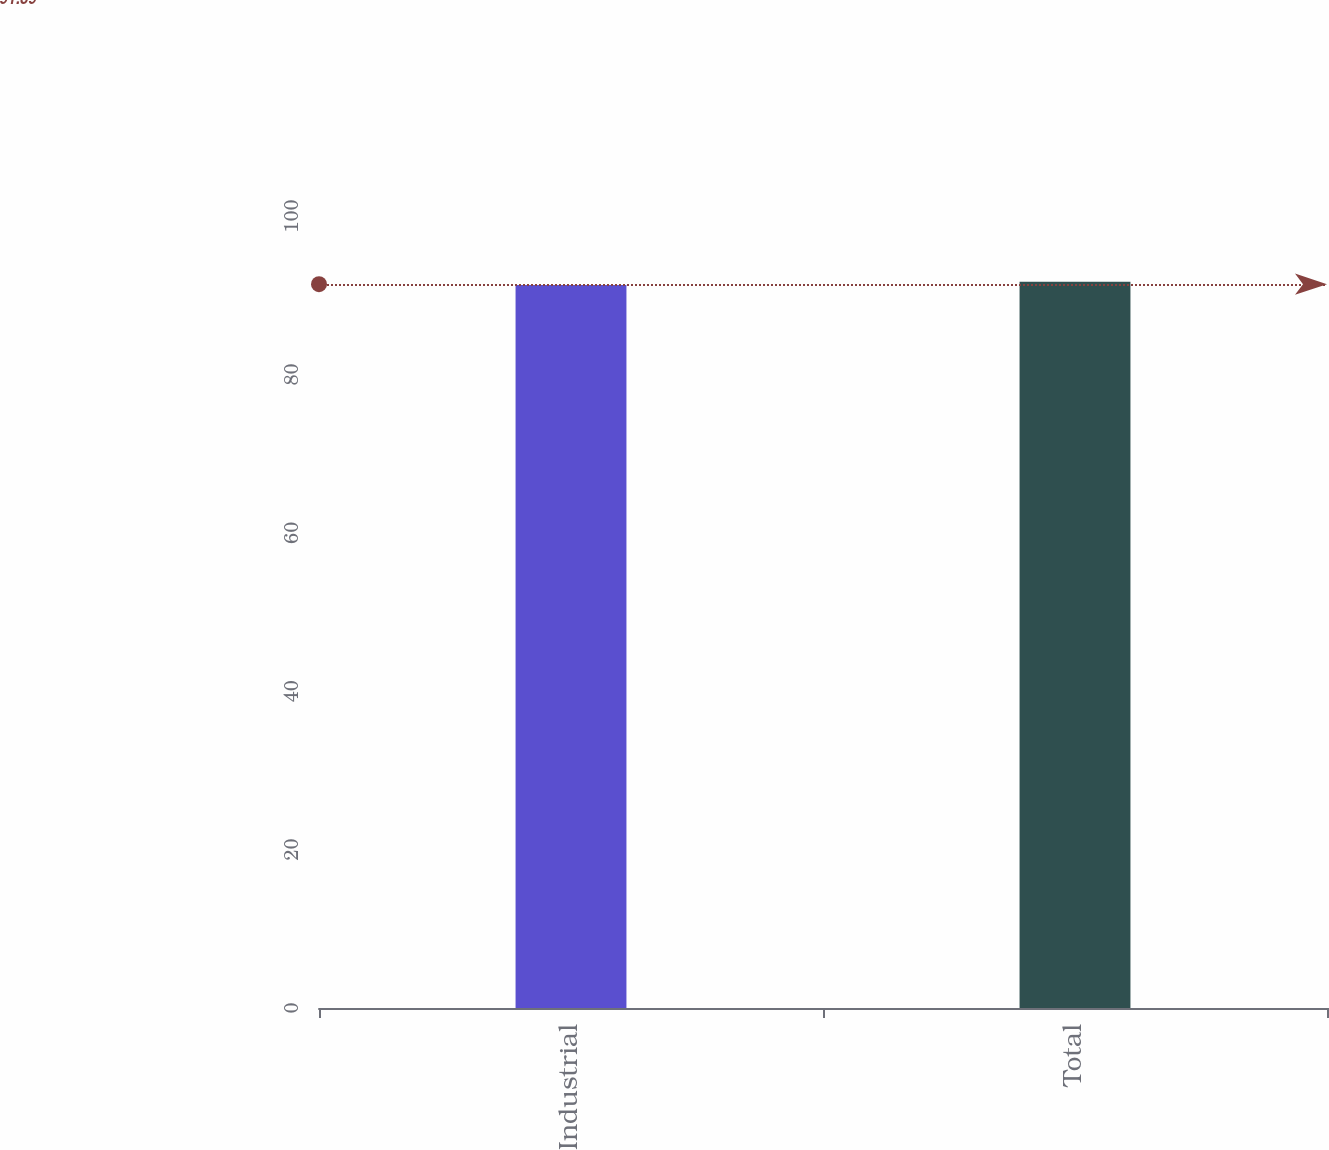Convert chart to OTSL. <chart><loc_0><loc_0><loc_500><loc_500><bar_chart><fcel>Industrial<fcel>Total<nl><fcel>91.3<fcel>91.7<nl></chart> 